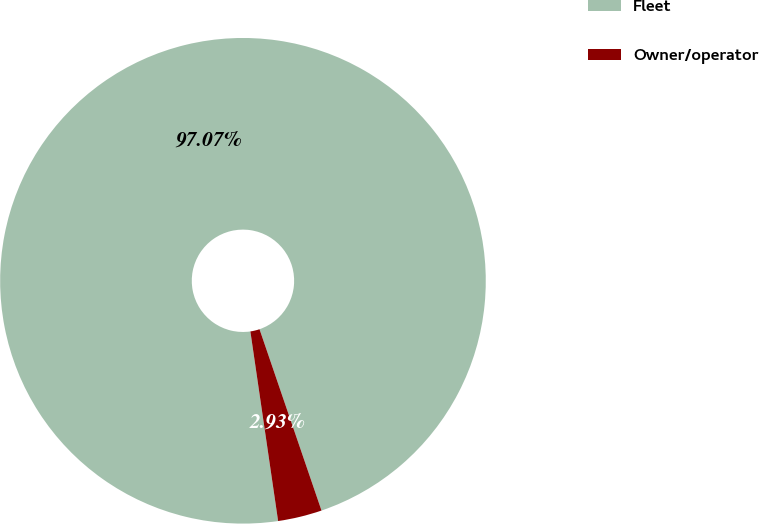Convert chart to OTSL. <chart><loc_0><loc_0><loc_500><loc_500><pie_chart><fcel>Fleet<fcel>Owner/operator<nl><fcel>97.07%<fcel>2.93%<nl></chart> 